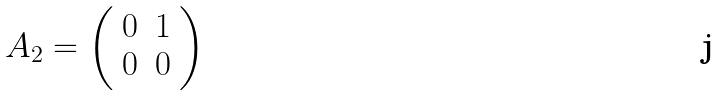<formula> <loc_0><loc_0><loc_500><loc_500>A _ { 2 } = \left ( \begin{array} { c c } 0 & 1 \\ 0 & 0 \\ \end{array} \right )</formula> 